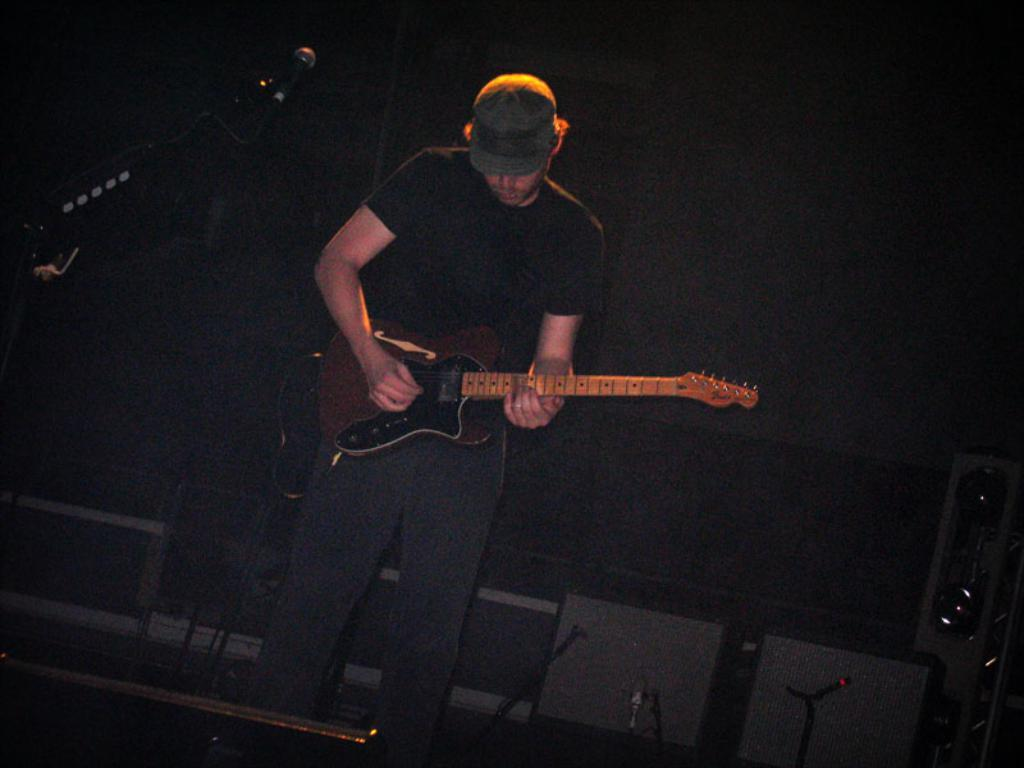What is the man in the image doing? The man is playing the guitar. What object is the man holding in the image? The man is holding a guitar. What can be seen in the background of the image? There is a machine and a wall in the background of the image. How would you describe the lighting in the image? The background of the image is dark. What type of locket is the man wearing in the image? There is no locket visible on the man in the image. Is the man wearing a hat in the image? The man is not wearing a hat in the image. 